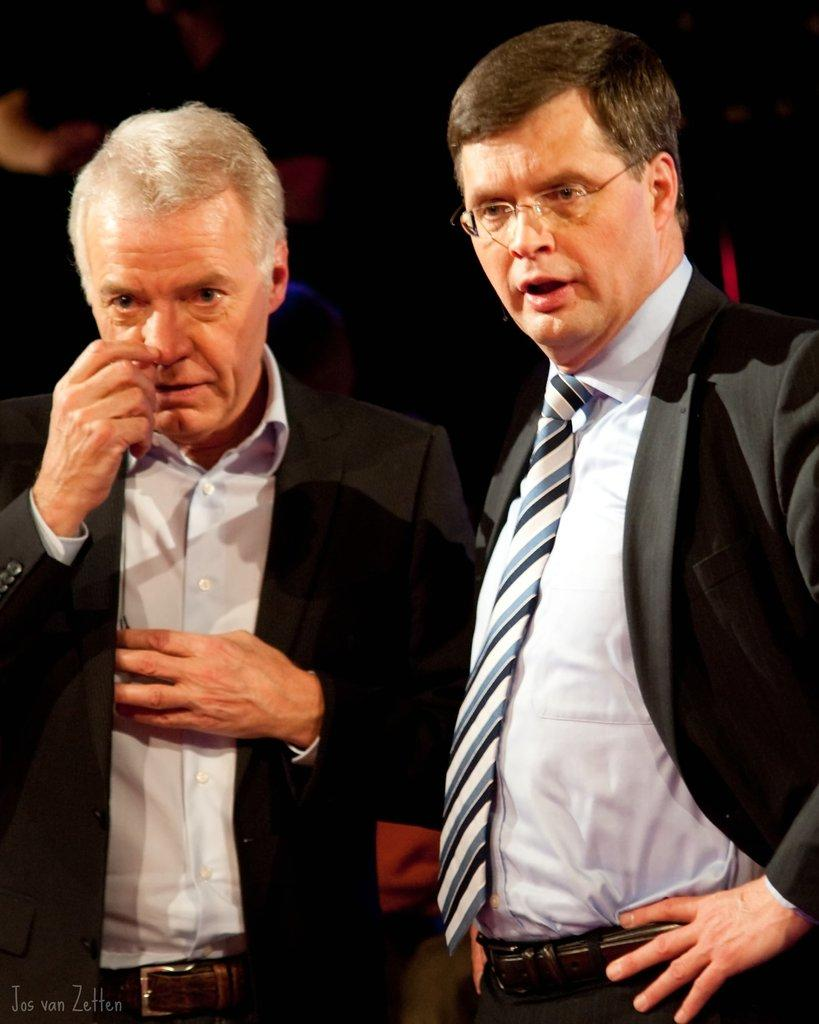How many people are in the image? There are two people standing in the image. What can be observed about the background of the image? The background of the image is dark. Is there any additional information or marking on the image? Yes, there is a watermark on the image. What type of linen is being used as a prop in the image? There is no linen present in the image. What caused the two people to stand in the image? The facts provided do not give any information about the reason or cause for the two people standing in the image. 